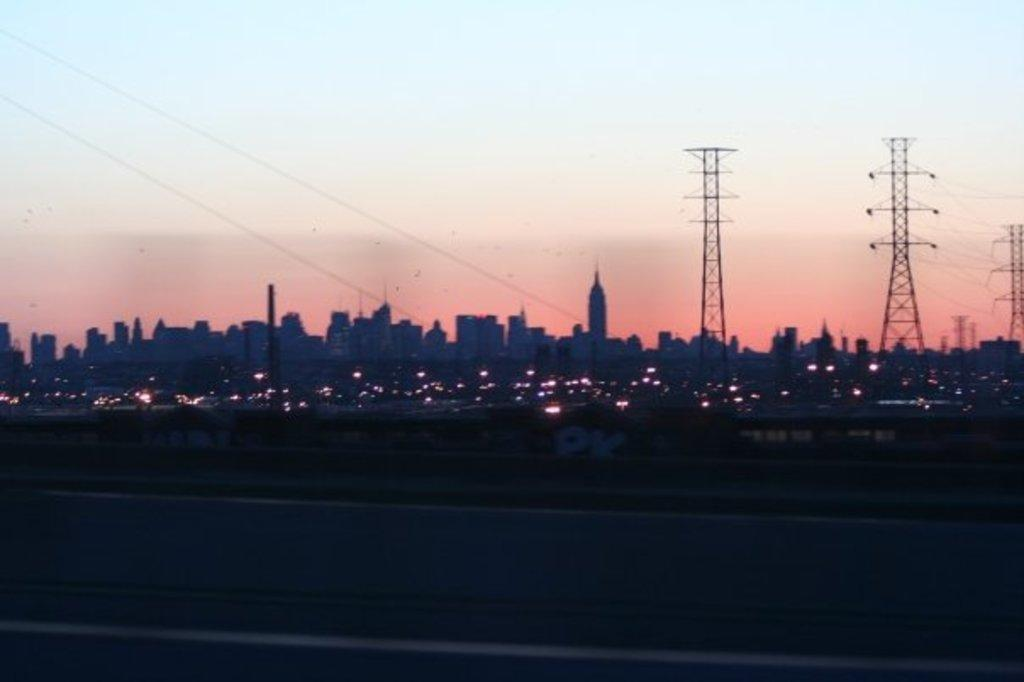What type of structures can be seen in the image? There are buildings in the image. What else is visible in the image besides the buildings? There are lights, wires, and cell phone towers visible in the image. What is the condition of the sky in the image? The sky is visible in the image. What type of disease is being treated in the image? There is no indication of a disease or medical treatment in the image. What type of connection is being established in the image? There is no indication of a connection being established in the image. 